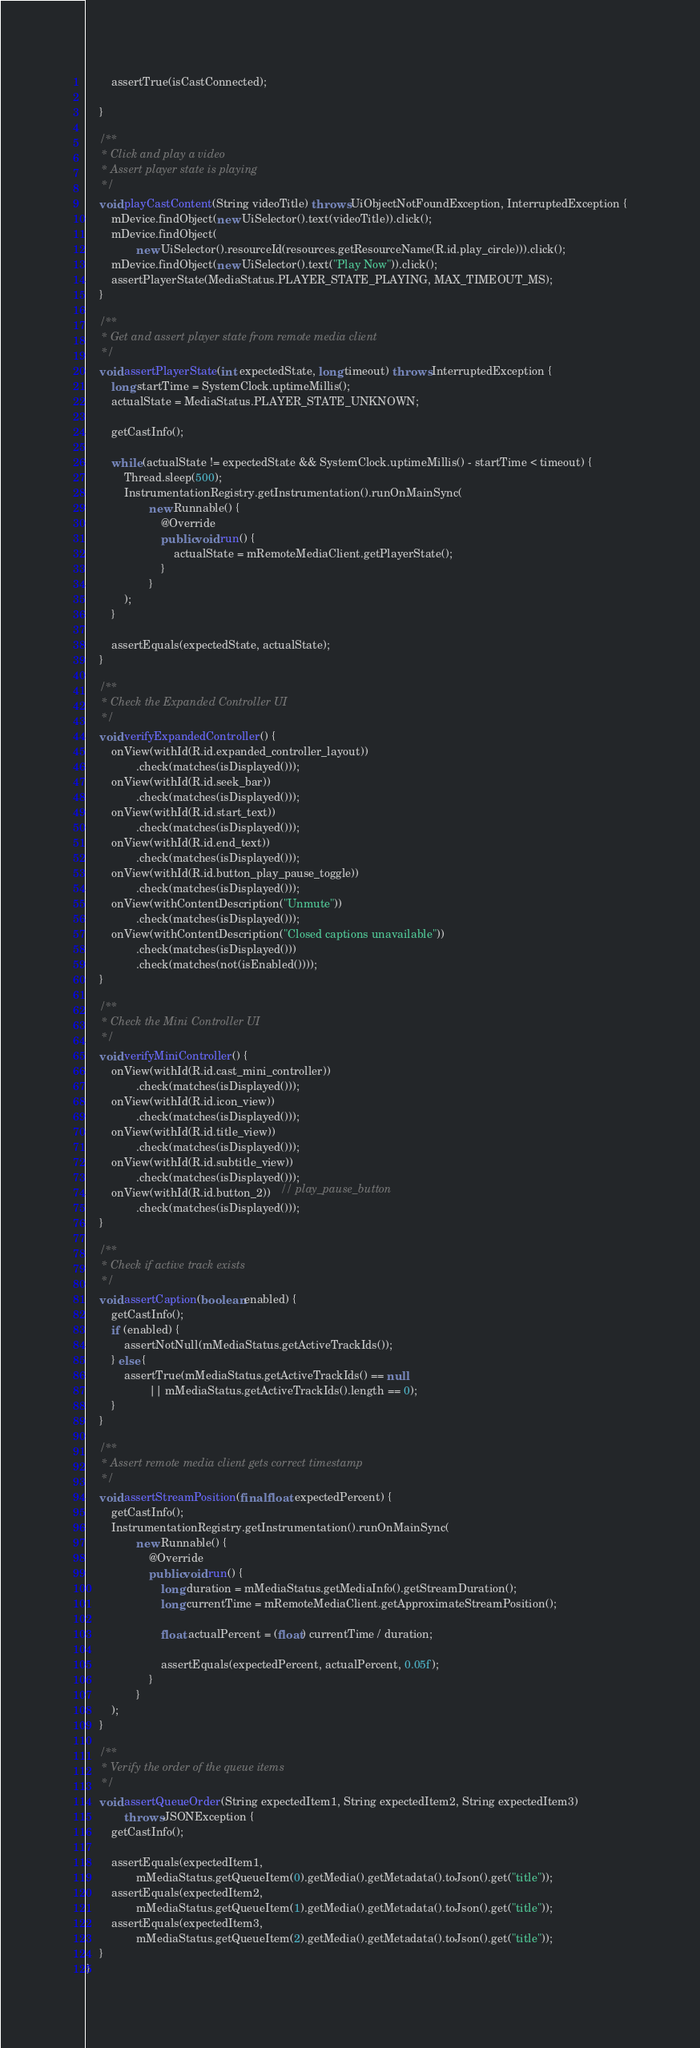<code> <loc_0><loc_0><loc_500><loc_500><_Java_>        assertTrue(isCastConnected);

    }

    /**
     * Click and play a video
     * Assert player state is playing
     */
    void playCastContent(String videoTitle) throws UiObjectNotFoundException, InterruptedException {
        mDevice.findObject(new UiSelector().text(videoTitle)).click();
        mDevice.findObject(
                new UiSelector().resourceId(resources.getResourceName(R.id.play_circle))).click();
        mDevice.findObject(new UiSelector().text("Play Now")).click();
        assertPlayerState(MediaStatus.PLAYER_STATE_PLAYING, MAX_TIMEOUT_MS);
    }

    /**
     * Get and assert player state from remote media client
     */
    void assertPlayerState(int expectedState, long timeout) throws InterruptedException {
        long startTime = SystemClock.uptimeMillis();
        actualState = MediaStatus.PLAYER_STATE_UNKNOWN;

        getCastInfo();

        while (actualState != expectedState && SystemClock.uptimeMillis() - startTime < timeout) {
            Thread.sleep(500);
            InstrumentationRegistry.getInstrumentation().runOnMainSync(
                    new Runnable() {
                        @Override
                        public void run() {
                            actualState = mRemoteMediaClient.getPlayerState();
                        }
                    }
            );
        }

        assertEquals(expectedState, actualState);
    }

    /**
     * Check the Expanded Controller UI
     */
    void verifyExpandedController() {
        onView(withId(R.id.expanded_controller_layout))
                .check(matches(isDisplayed()));
        onView(withId(R.id.seek_bar))
                .check(matches(isDisplayed()));
        onView(withId(R.id.start_text))
                .check(matches(isDisplayed()));
        onView(withId(R.id.end_text))
                .check(matches(isDisplayed()));
        onView(withId(R.id.button_play_pause_toggle))
                .check(matches(isDisplayed()));
        onView(withContentDescription("Unmute"))
                .check(matches(isDisplayed()));
        onView(withContentDescription("Closed captions unavailable"))
                .check(matches(isDisplayed()))
                .check(matches(not(isEnabled())));
    }

    /**
     * Check the Mini Controller UI
     */
    void verifyMiniController() {
        onView(withId(R.id.cast_mini_controller))
                .check(matches(isDisplayed()));
        onView(withId(R.id.icon_view))
                .check(matches(isDisplayed()));
        onView(withId(R.id.title_view))
                .check(matches(isDisplayed()));
        onView(withId(R.id.subtitle_view))
                .check(matches(isDisplayed()));
        onView(withId(R.id.button_2))   // play_pause_button
                .check(matches(isDisplayed()));
    }

    /**
     * Check if active track exists
     */
    void assertCaption(boolean enabled) {
        getCastInfo();
        if (enabled) {
            assertNotNull(mMediaStatus.getActiveTrackIds());
        } else {
            assertTrue(mMediaStatus.getActiveTrackIds() == null
                    || mMediaStatus.getActiveTrackIds().length == 0);
        }
    }

    /**
     * Assert remote media client gets correct timestamp
     */
    void assertStreamPosition(final float expectedPercent) {
        getCastInfo();
        InstrumentationRegistry.getInstrumentation().runOnMainSync(
                new Runnable() {
                    @Override
                    public void run() {
                        long duration = mMediaStatus.getMediaInfo().getStreamDuration();
                        long currentTime = mRemoteMediaClient.getApproximateStreamPosition();

                        float actualPercent = (float) currentTime / duration;

                        assertEquals(expectedPercent, actualPercent, 0.05f);
                    }
                }
        );
    }

    /**
     * Verify the order of the queue items
     */
    void assertQueueOrder(String expectedItem1, String expectedItem2, String expectedItem3)
            throws JSONException {
        getCastInfo();

        assertEquals(expectedItem1,
                mMediaStatus.getQueueItem(0).getMedia().getMetadata().toJson().get("title"));
        assertEquals(expectedItem2,
                mMediaStatus.getQueueItem(1).getMedia().getMetadata().toJson().get("title"));
        assertEquals(expectedItem3,
                mMediaStatus.getQueueItem(2).getMedia().getMetadata().toJson().get("title"));
    }
}
</code> 